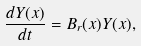<formula> <loc_0><loc_0><loc_500><loc_500>\frac { d Y ( x ) } { d t } = B _ { r } ( x ) Y ( x ) ,</formula> 